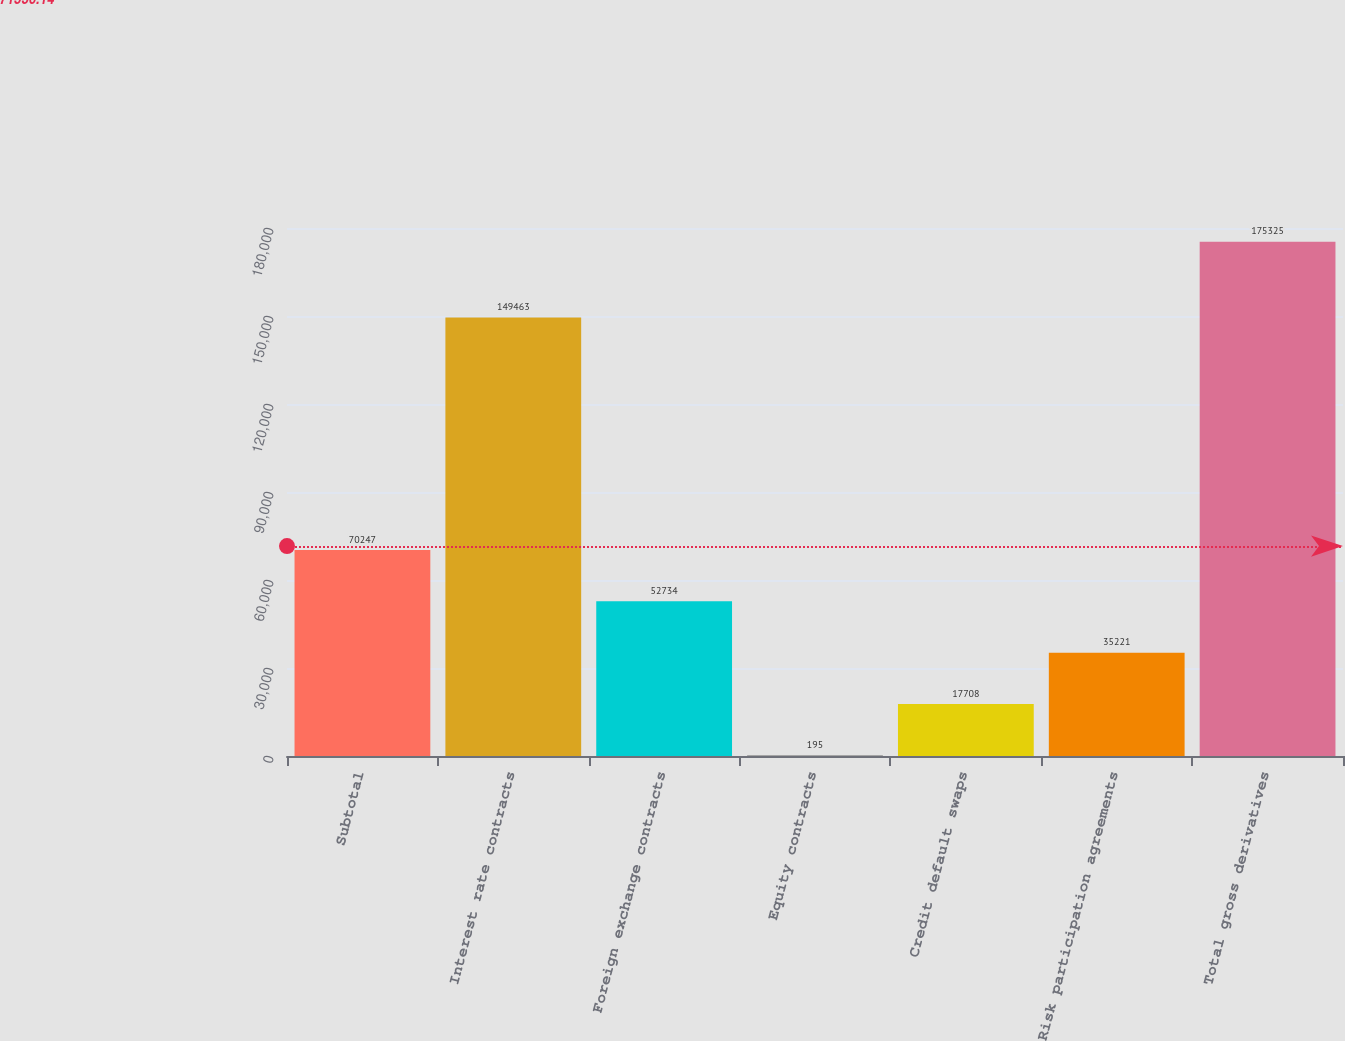Convert chart. <chart><loc_0><loc_0><loc_500><loc_500><bar_chart><fcel>Subtotal<fcel>Interest rate contracts<fcel>Foreign exchange contracts<fcel>Equity contracts<fcel>Credit default swaps<fcel>Risk participation agreements<fcel>Total gross derivatives<nl><fcel>70247<fcel>149463<fcel>52734<fcel>195<fcel>17708<fcel>35221<fcel>175325<nl></chart> 